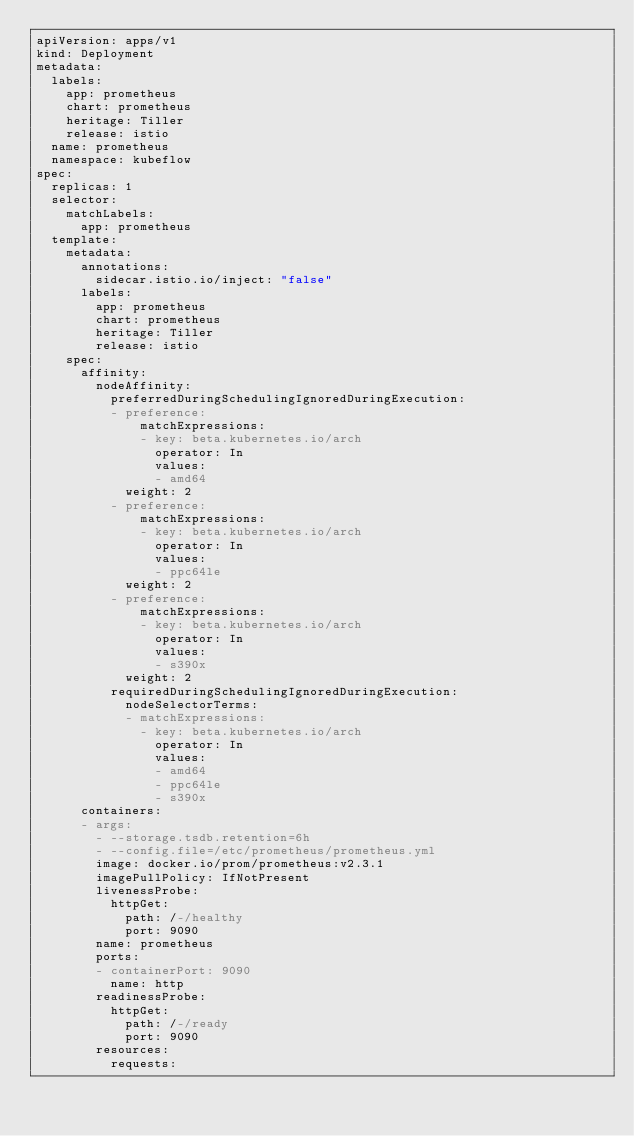<code> <loc_0><loc_0><loc_500><loc_500><_YAML_>apiVersion: apps/v1
kind: Deployment
metadata:
  labels:
    app: prometheus
    chart: prometheus
    heritage: Tiller
    release: istio
  name: prometheus
  namespace: kubeflow
spec:
  replicas: 1
  selector:
    matchLabels:
      app: prometheus
  template:
    metadata:
      annotations:
        sidecar.istio.io/inject: "false"
      labels:
        app: prometheus
        chart: prometheus
        heritage: Tiller
        release: istio
    spec:
      affinity:
        nodeAffinity:
          preferredDuringSchedulingIgnoredDuringExecution:
          - preference:
              matchExpressions:
              - key: beta.kubernetes.io/arch
                operator: In
                values:
                - amd64
            weight: 2
          - preference:
              matchExpressions:
              - key: beta.kubernetes.io/arch
                operator: In
                values:
                - ppc64le
            weight: 2
          - preference:
              matchExpressions:
              - key: beta.kubernetes.io/arch
                operator: In
                values:
                - s390x
            weight: 2
          requiredDuringSchedulingIgnoredDuringExecution:
            nodeSelectorTerms:
            - matchExpressions:
              - key: beta.kubernetes.io/arch
                operator: In
                values:
                - amd64
                - ppc64le
                - s390x
      containers:
      - args:
        - --storage.tsdb.retention=6h
        - --config.file=/etc/prometheus/prometheus.yml
        image: docker.io/prom/prometheus:v2.3.1
        imagePullPolicy: IfNotPresent
        livenessProbe:
          httpGet:
            path: /-/healthy
            port: 9090
        name: prometheus
        ports:
        - containerPort: 9090
          name: http
        readinessProbe:
          httpGet:
            path: /-/ready
            port: 9090
        resources:
          requests:</code> 